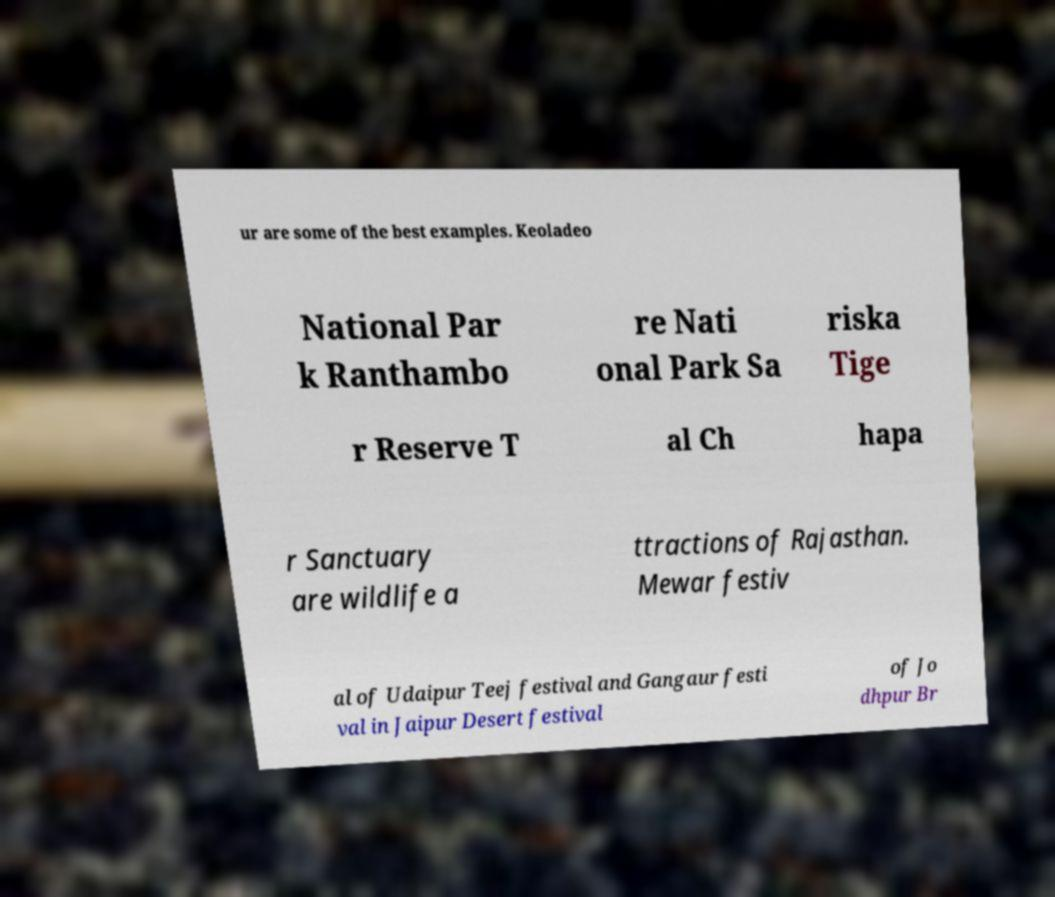Please identify and transcribe the text found in this image. ur are some of the best examples. Keoladeo National Par k Ranthambo re Nati onal Park Sa riska Tige r Reserve T al Ch hapa r Sanctuary are wildlife a ttractions of Rajasthan. Mewar festiv al of Udaipur Teej festival and Gangaur festi val in Jaipur Desert festival of Jo dhpur Br 